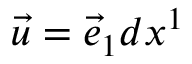<formula> <loc_0><loc_0><loc_500><loc_500>{ \vec { u } } = { \vec { e } } _ { 1 } d x ^ { 1 }</formula> 